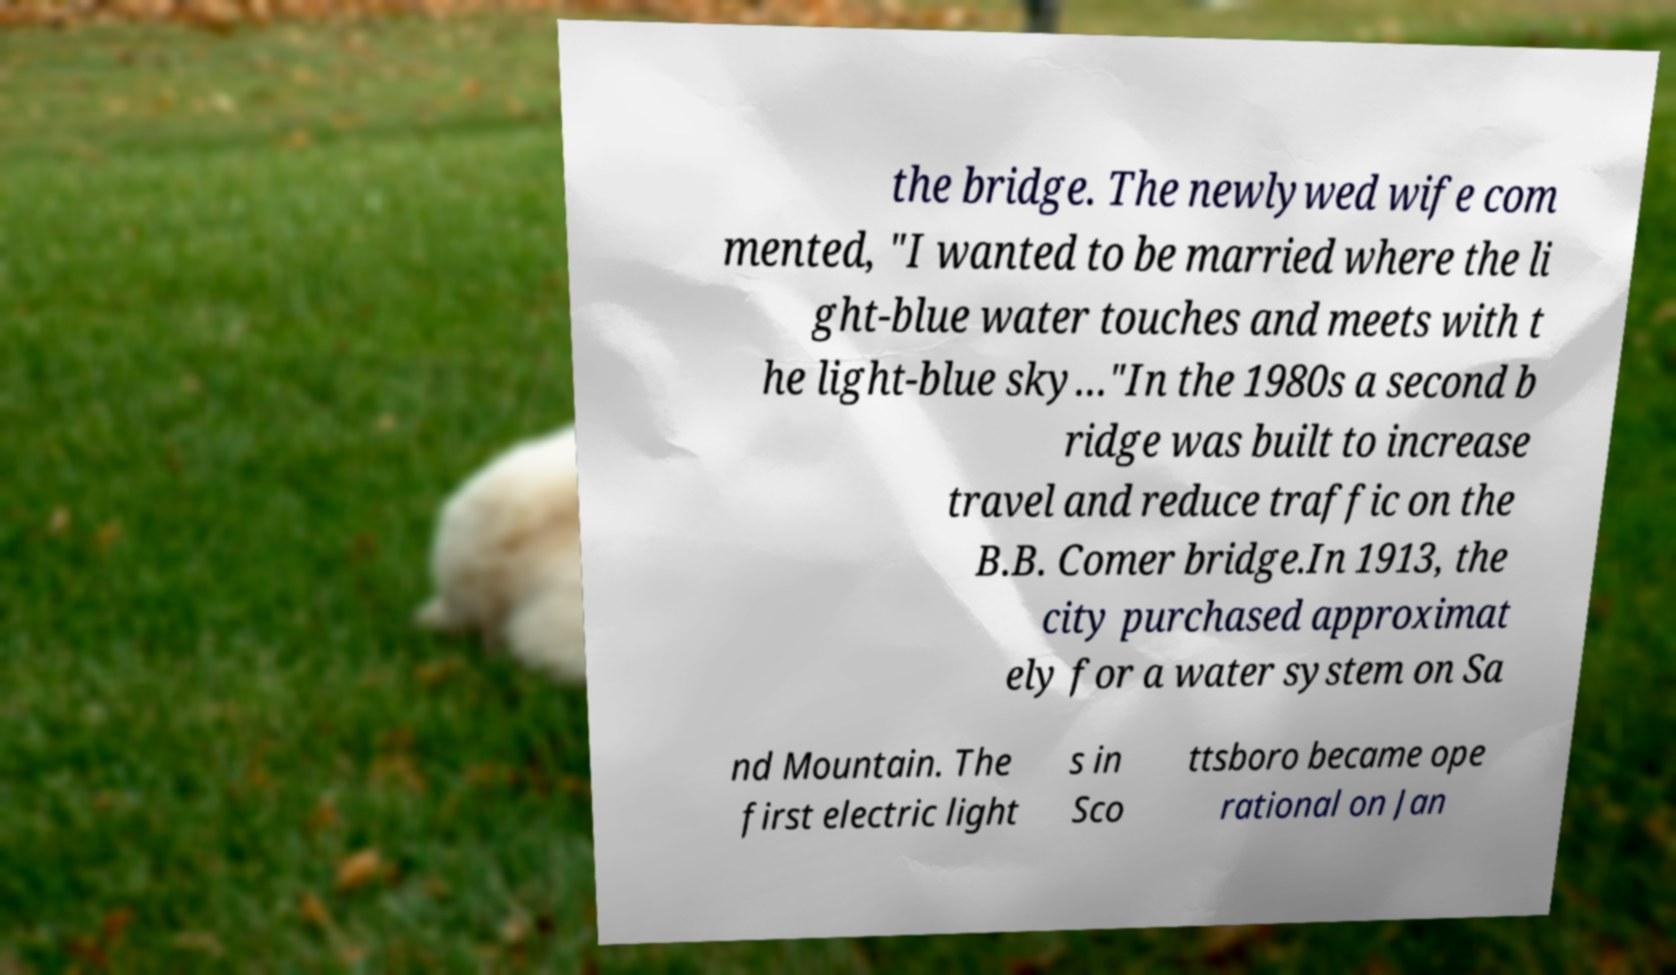Can you accurately transcribe the text from the provided image for me? the bridge. The newlywed wife com mented, "I wanted to be married where the li ght-blue water touches and meets with t he light-blue sky…"In the 1980s a second b ridge was built to increase travel and reduce traffic on the B.B. Comer bridge.In 1913, the city purchased approximat ely for a water system on Sa nd Mountain. The first electric light s in Sco ttsboro became ope rational on Jan 